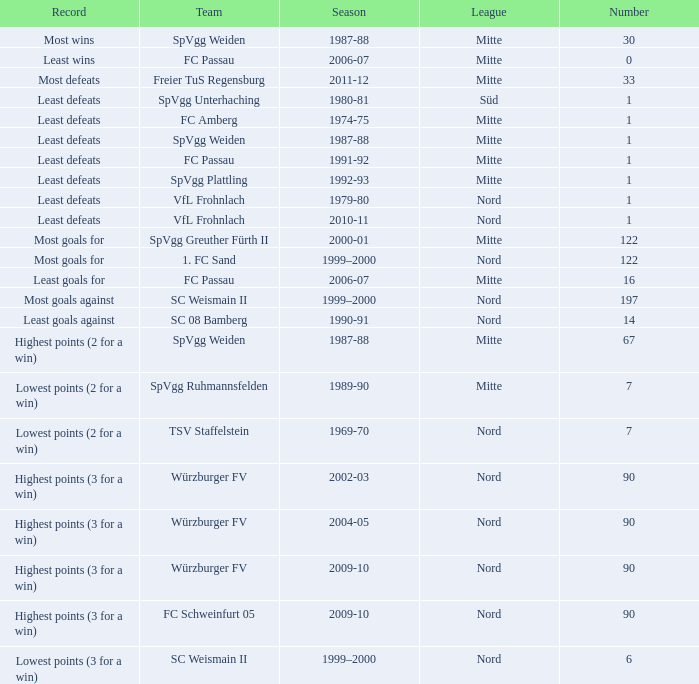Which league holds the record for the most victories? Mitte. 